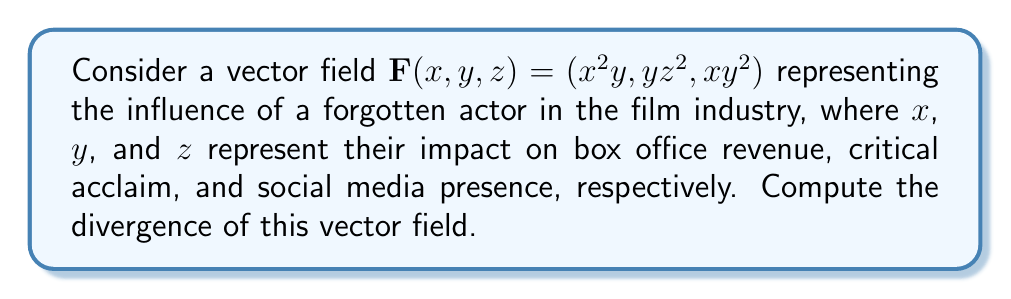Can you solve this math problem? To compute the divergence of the vector field $\mathbf{F}(x,y,z) = (x^2y, yz^2, xy^2)$, we need to use the divergence formula in Cartesian coordinates:

$$\text{div}\mathbf{F} = \nabla \cdot \mathbf{F} = \frac{\partial F_x}{\partial x} + \frac{\partial F_y}{\partial y} + \frac{\partial F_z}{\partial z}$$

Let's calculate each partial derivative:

1. $\frac{\partial F_x}{\partial x} = \frac{\partial}{\partial x}(x^2y) = 2xy$

2. $\frac{\partial F_y}{\partial y} = \frac{\partial}{\partial y}(yz^2) = z^2$

3. $\frac{\partial F_z}{\partial z} = \frac{\partial}{\partial z}(xy^2) = 0$

Now, we sum these partial derivatives:

$$\text{div}\mathbf{F} = \frac{\partial F_x}{\partial x} + \frac{\partial F_y}{\partial y} + \frac{\partial F_z}{\partial z} = 2xy + z^2 + 0 = 2xy + z^2$$

This result represents the rate at which the actor's influence is spreading or concentrating at any point $(x,y,z)$ in the industry space.
Answer: $2xy + z^2$ 